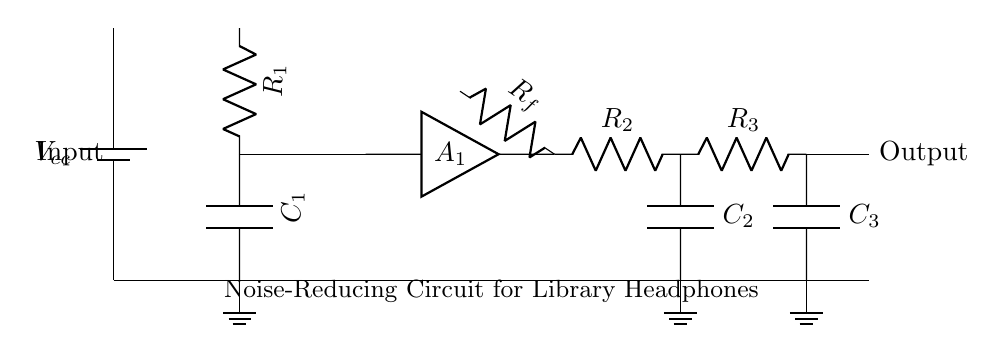What type of capacitor is used in the input stage? The capacitor in the input stage is labeled as C1, and it is connected after the resistor R1, indicating its role in filtering noise from the input.
Answer: Capacitor What is the purpose of the amplifier in this circuit? The amplifier, labeled A1, is responsible for increasing the signal strength after it has passed through the input filter (C1), which helps to ensure that the audio signal remains clear and audible.
Answer: Increase signal strength How many resistors are present in the circuit? The circuit contains three resistors: R1, R2, and R3, as indicated by their labels in the diagram.
Answer: Three What is the function of the low-pass filter in this circuit? The low-pass filter, which consists of resistor R2 and capacitor C2, is used to allow low-frequency audio signals to pass through while attenuating high-frequency noise, enhancing the overall sound quality of the headphones.
Answer: Noise attenuation What is the output connection of the circuit? The output connection is made after the final resistor (R3) and capacitor (C3), leading to point 12 in the diagram. This point signifies where the processed audio signal exits the circuit for the headphones.
Answer: Point 12 